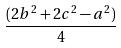Convert formula to latex. <formula><loc_0><loc_0><loc_500><loc_500>\frac { ( 2 b ^ { 2 } + 2 c ^ { 2 } - a ^ { 2 } ) } { 4 }</formula> 